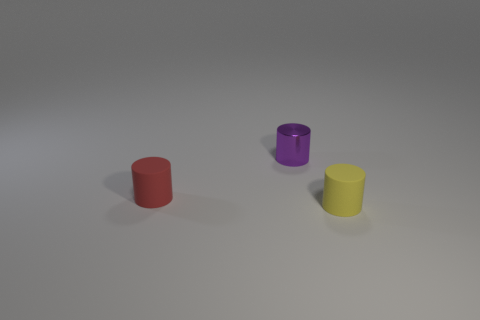Add 1 rubber cylinders. How many objects exist? 4 Add 1 red cylinders. How many red cylinders exist? 2 Subtract 0 brown balls. How many objects are left? 3 Subtract all yellow rubber objects. Subtract all tiny yellow objects. How many objects are left? 1 Add 1 shiny objects. How many shiny objects are left? 2 